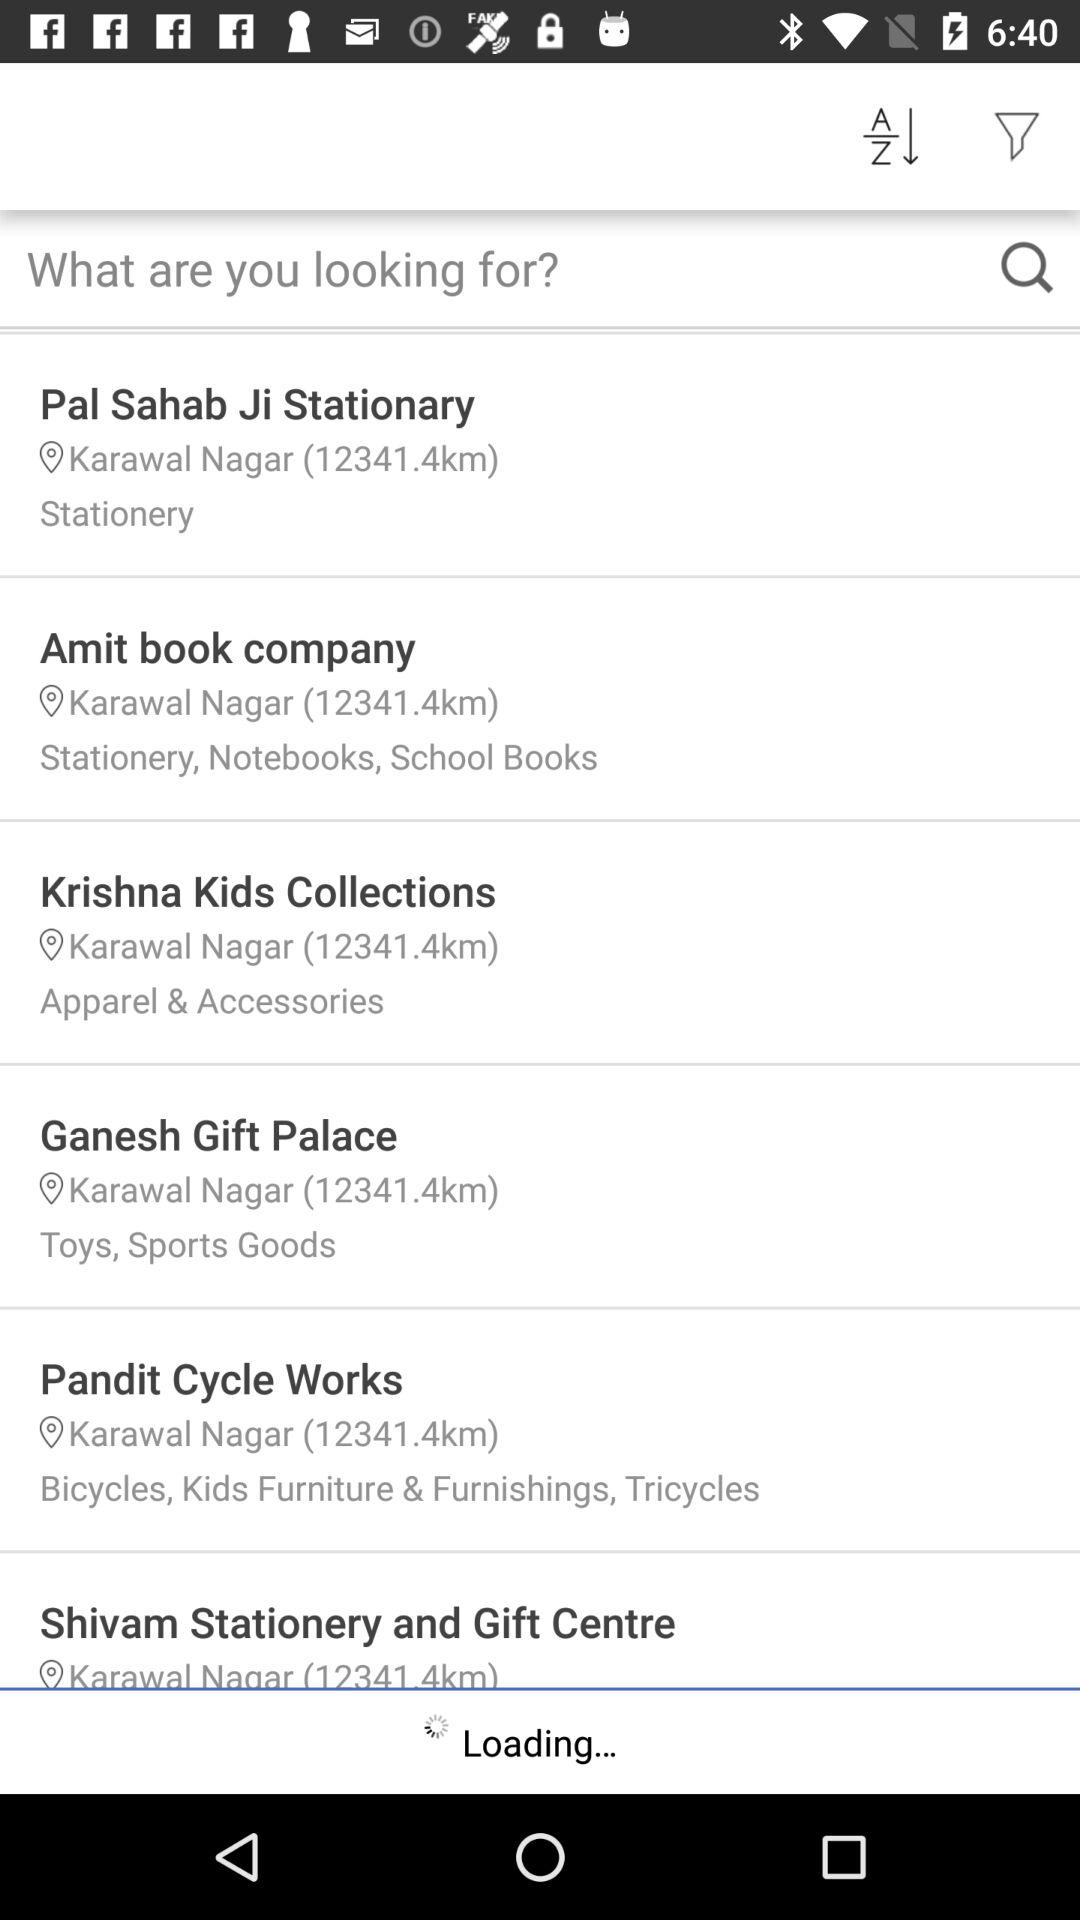What is the location of "Amit book company"? The location is Karawal Nagar. 